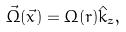<formula> <loc_0><loc_0><loc_500><loc_500>\vec { \Omega } ( \vec { x } ) = \Omega ( r ) \hat { k } _ { z } ,</formula> 